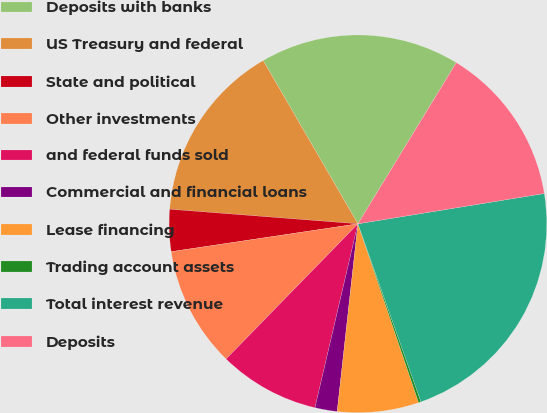<chart> <loc_0><loc_0><loc_500><loc_500><pie_chart><fcel>Deposits with banks<fcel>US Treasury and federal<fcel>State and political<fcel>Other investments<fcel>and federal funds sold<fcel>Commercial and financial loans<fcel>Lease financing<fcel>Trading account assets<fcel>Total interest revenue<fcel>Deposits<nl><fcel>17.09%<fcel>15.4%<fcel>3.59%<fcel>10.34%<fcel>8.65%<fcel>1.9%<fcel>6.96%<fcel>0.21%<fcel>22.15%<fcel>13.71%<nl></chart> 